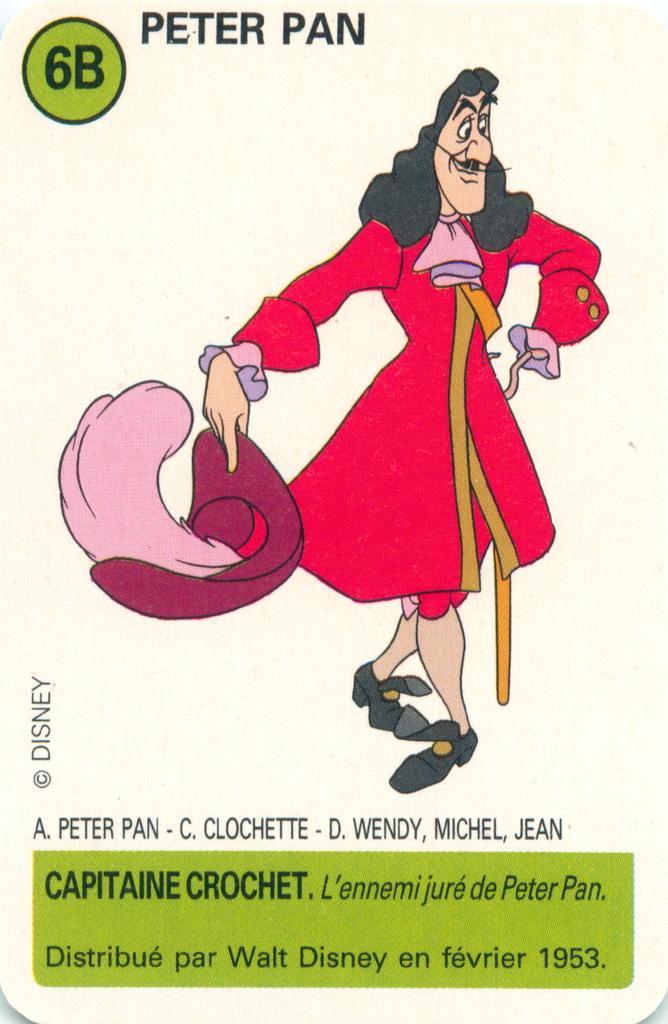Can you describe this image briefly? In the picture I can see an image of a person wearing pink frock is standing and there is something written above and below it. 